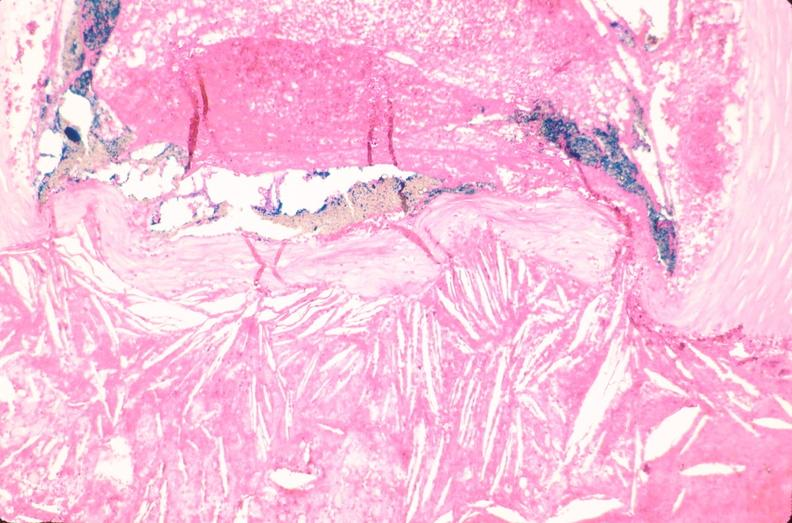what is present?
Answer the question using a single word or phrase. Cardiovascular 